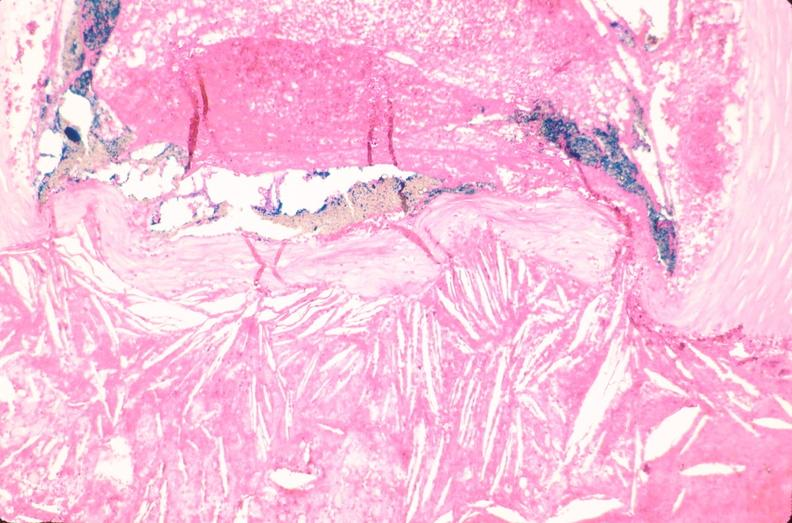what is present?
Answer the question using a single word or phrase. Cardiovascular 